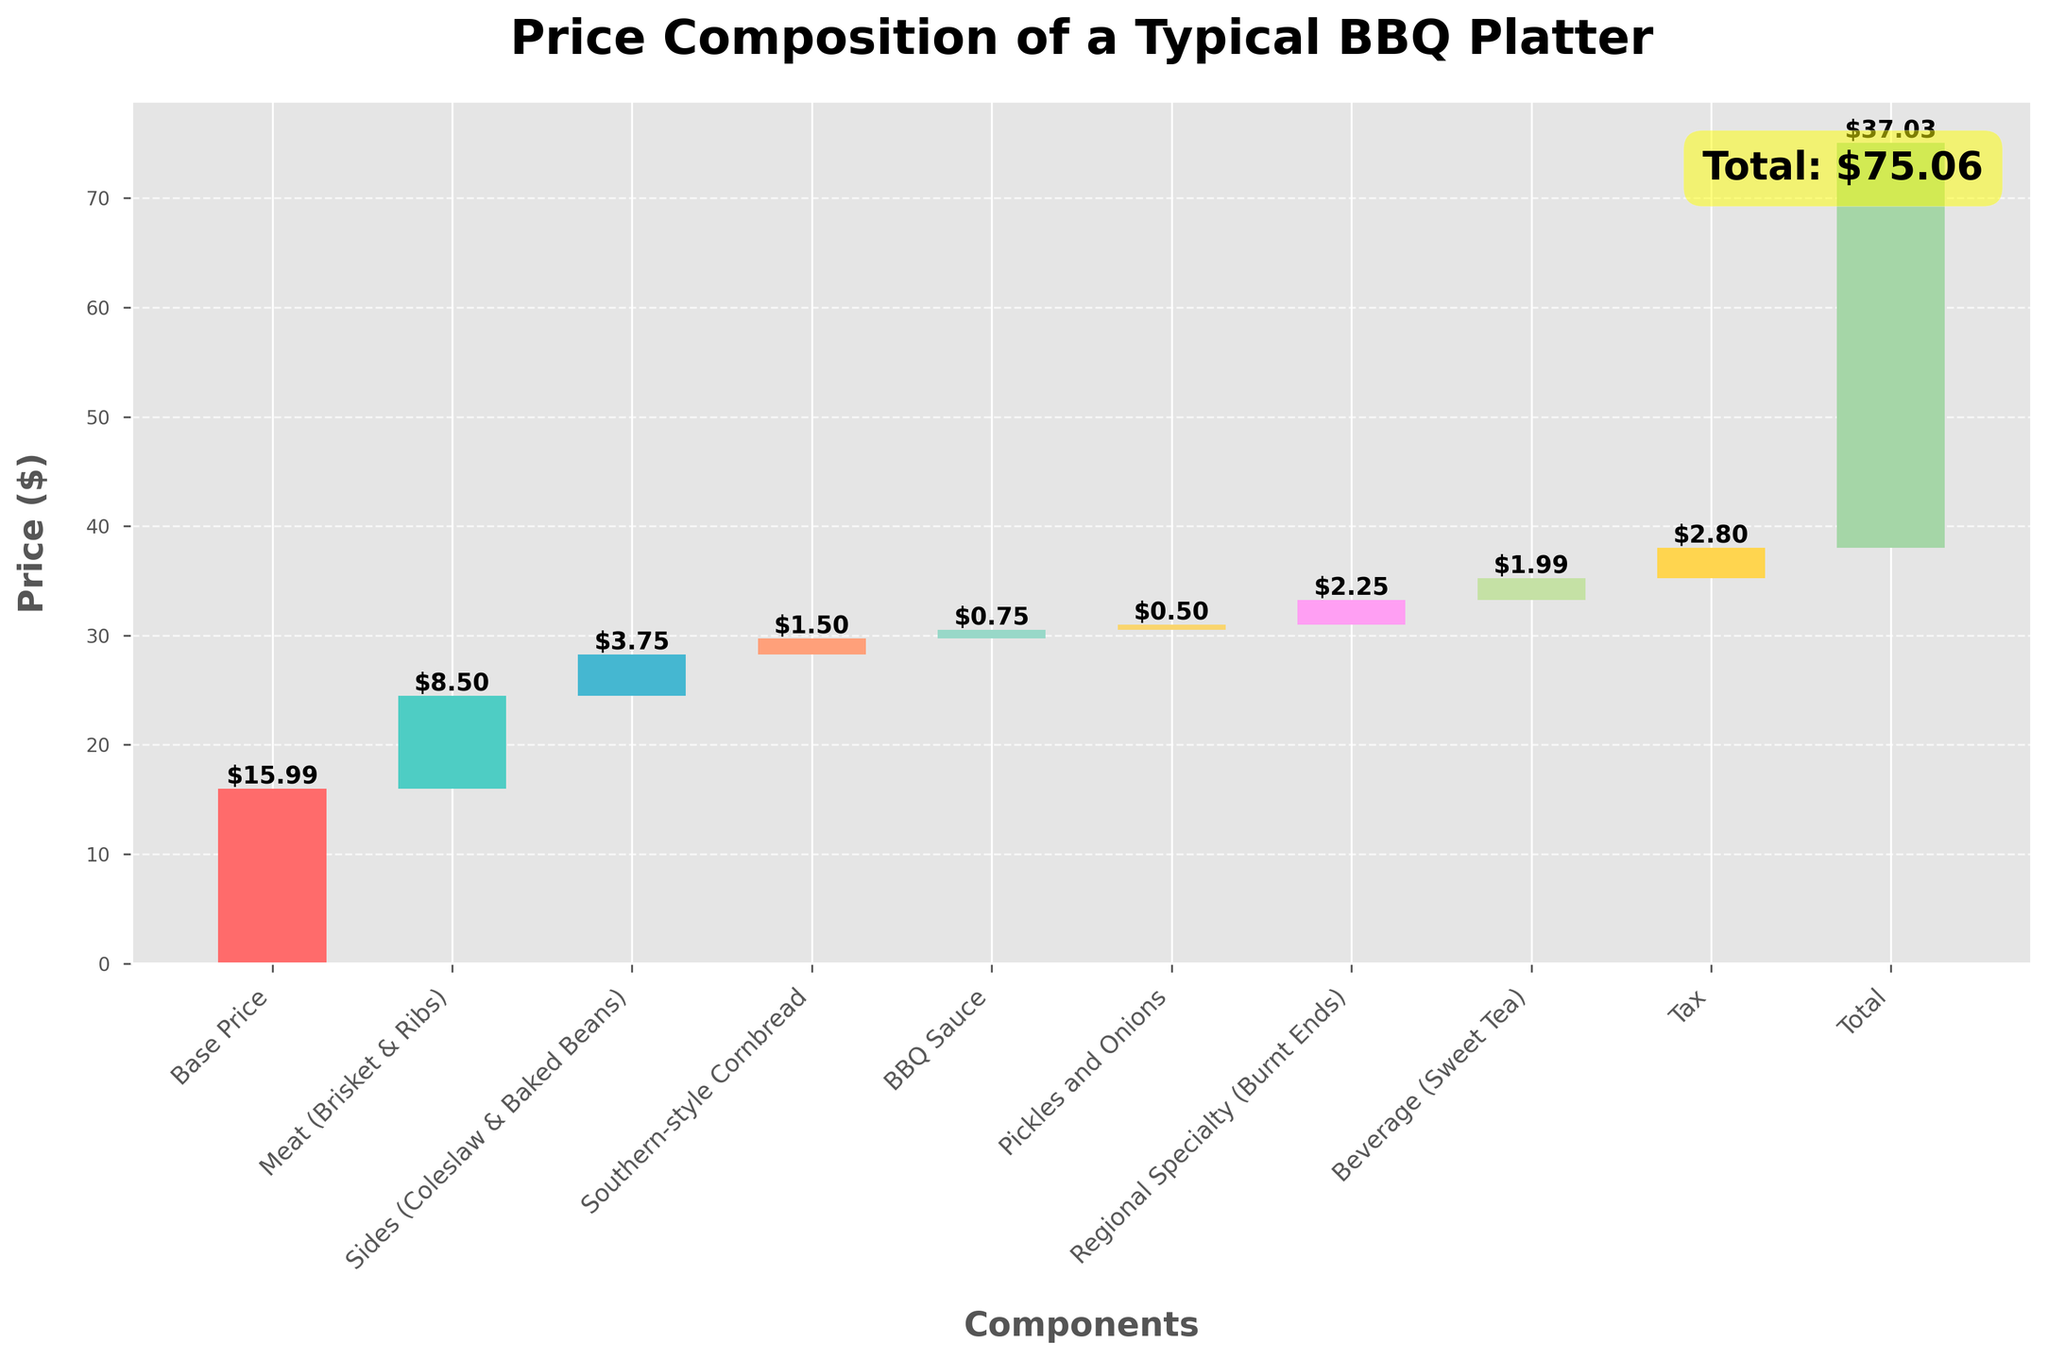What is the total price of the BBQ platter? The total price is clearly marked at the end of the chart, indicated as "Total: $37.03".
Answer: $37.03 How much do the meat components (Brisket & Ribs) add to the base price? The additional cost for meat is given directly in the chart as "+$8.50".
Answer: $8.50 Which component has the smallest incremental value, and what is its value? By examining the incremental values next to each category, the smallest value is "+$0.50" for Pickles and Onions.
Answer: $0.50 What is the combined cost of the Sides and the Southern-style Cornbread? The values for Sides and Cornbread are $3.75 and $1.50, respectively. Adding these together gives $3.75 + $1.50 = $5.25.
Answer: $5.25 Which category has a higher incremental cost, the beverage or the pickles and onions? By how much? The beverage (Sweet Tea) costs $1.99, while the pickles and onions cost $0.50. The difference is $1.99 - $0.50 = $1.49.
Answer: Beverage by $1.49 What is the cost difference between the base price and the cumulative price after adding the regional specialty? The cumulative price after the regional specialty (Burnt Ends) is $32.24, and the base price is $15.99. The difference is $32.24 - $15.99 = $16.25.
Answer: $16.25 After the base price, meat, and sides, what is the cumulative price? The base price is $15.99, adding meat ($8.50) and sides ($3.75) results in $15.99 + $8.50 + $3.75 = $28.24.
Answer: $28.24 If the tax were removed, what would the total price be? The total price with tax is $37.03. Removing the tax ($2.80) results in $37.03 - $2.80 = $34.23.
Answer: $34.23 